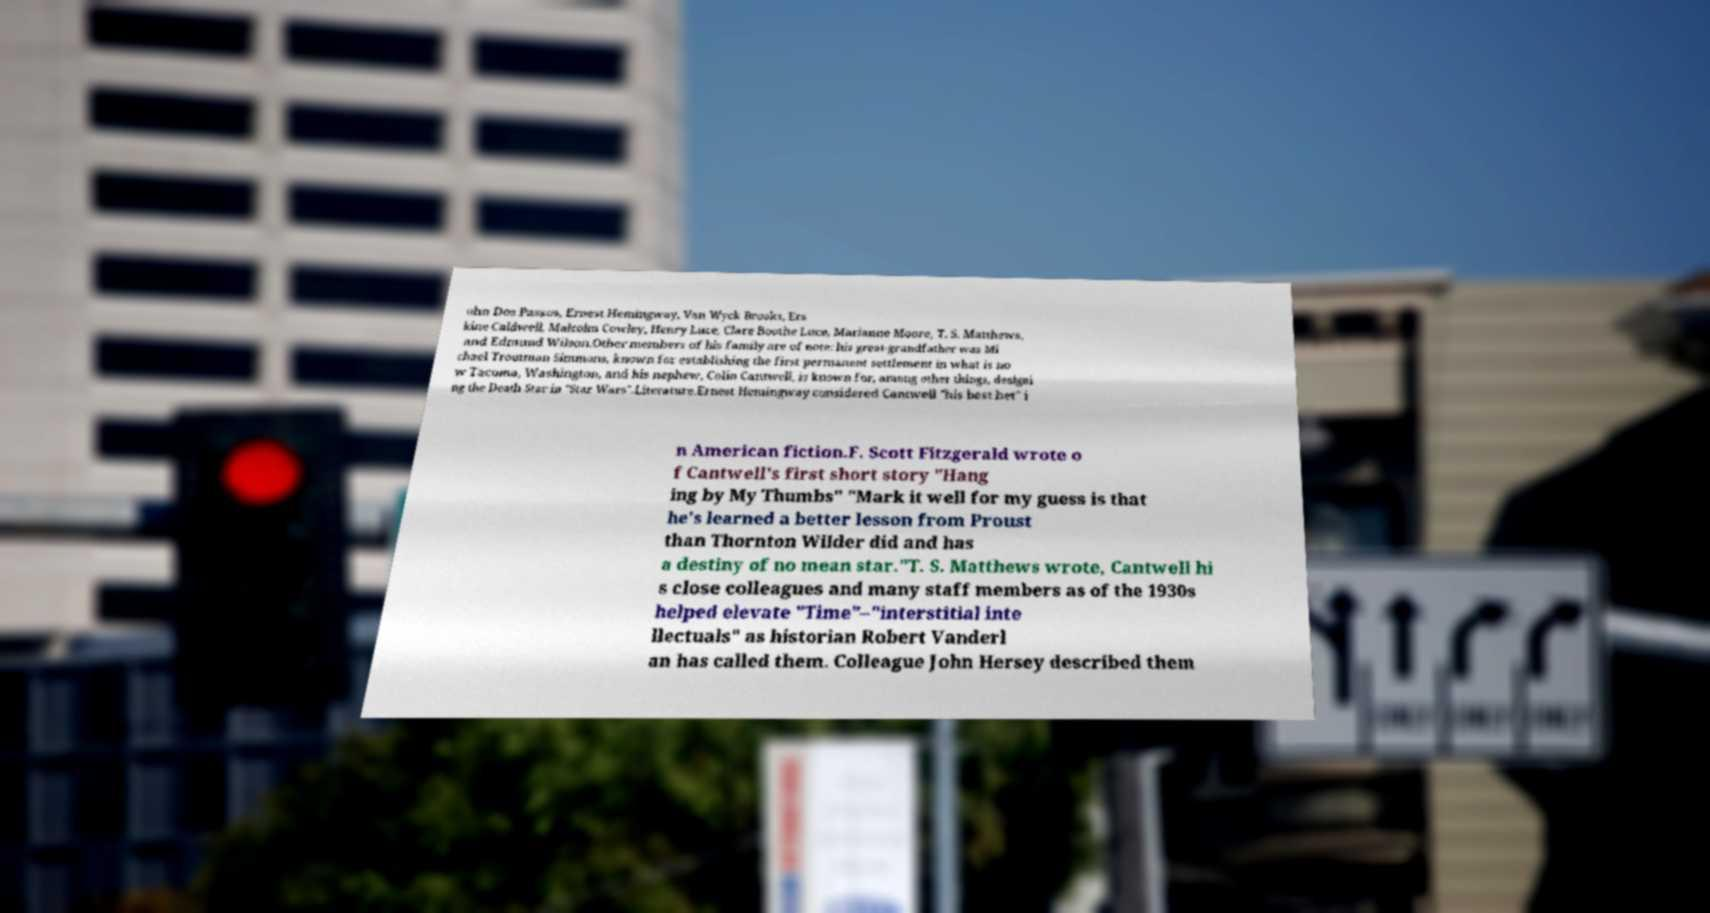Please read and relay the text visible in this image. What does it say? ohn Dos Passos, Ernest Hemingway, Van Wyck Brooks, Ers kine Caldwell, Malcolm Cowley, Henry Luce, Clare Boothe Luce, Marianne Moore, T. S. Matthews, and Edmund Wilson.Other members of his family are of note: his great-grandfather was Mi chael Troutman Simmons, known for establishing the first permanent settlement in what is no w Tacoma, Washington, and his nephew, Colin Cantwell, is known for, among other things, designi ng the Death Star in "Star Wars".Literature.Ernest Hemingway considered Cantwell "his best bet" i n American fiction.F. Scott Fitzgerald wrote o f Cantwell's first short story "Hang ing by My Thumbs" "Mark it well for my guess is that he's learned a better lesson from Proust than Thornton Wilder did and has a destiny of no mean star."T. S. Matthews wrote, Cantwell hi s close colleagues and many staff members as of the 1930s helped elevate "Time"–"interstitial inte llectuals" as historian Robert Vanderl an has called them. Colleague John Hersey described them 